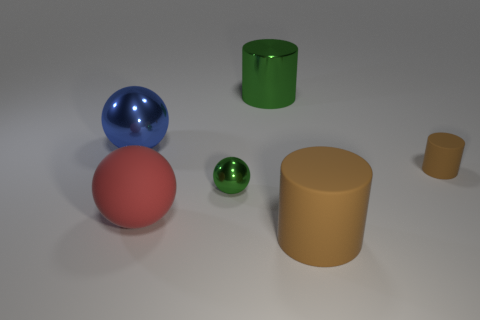There is a green shiny sphere; does it have the same size as the shiny object to the right of the tiny green shiny ball?
Your response must be concise. No. Is there a object that has the same color as the large metal cylinder?
Your answer should be compact. Yes. What size is the other cylinder that is made of the same material as the small brown cylinder?
Offer a terse response. Large. Is the big red thing made of the same material as the tiny cylinder?
Make the answer very short. Yes. There is a large matte object to the left of the green metallic object that is behind the metal sphere in front of the big blue ball; what is its color?
Offer a very short reply. Red. What is the shape of the big brown object?
Give a very brief answer. Cylinder. Do the small sphere and the cylinder on the left side of the big brown rubber cylinder have the same color?
Make the answer very short. Yes. Are there an equal number of big green metal cylinders that are behind the green metallic cylinder and tiny things?
Your response must be concise. No. How many other matte things are the same size as the blue object?
Provide a short and direct response. 2. There is a big object that is the same color as the small ball; what is its shape?
Offer a very short reply. Cylinder. 